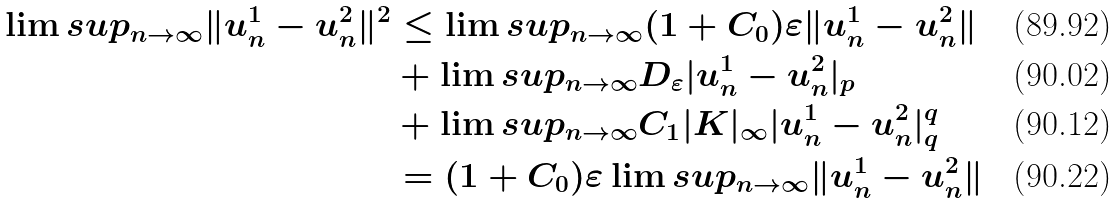<formula> <loc_0><loc_0><loc_500><loc_500>\lim s u p _ { n \to \infty } \| u _ { n } ^ { 1 } - u _ { n } ^ { 2 } \| ^ { 2 } & \leq \lim s u p _ { n \to \infty } ( 1 + C _ { 0 } ) \varepsilon \| u _ { n } ^ { 1 } - u _ { n } ^ { 2 } \| \\ & + \lim s u p _ { n \to \infty } D _ { \varepsilon } | u _ { n } ^ { 1 } - u _ { n } ^ { 2 } | _ { p } \\ & + \lim s u p _ { n \to \infty } C _ { 1 } | K | _ { \infty } | u _ { n } ^ { 1 } - u _ { n } ^ { 2 } | _ { q } ^ { q } \\ & = ( 1 + C _ { 0 } ) \varepsilon \lim s u p _ { n \to \infty } \| u _ { n } ^ { 1 } - u _ { n } ^ { 2 } \|</formula> 